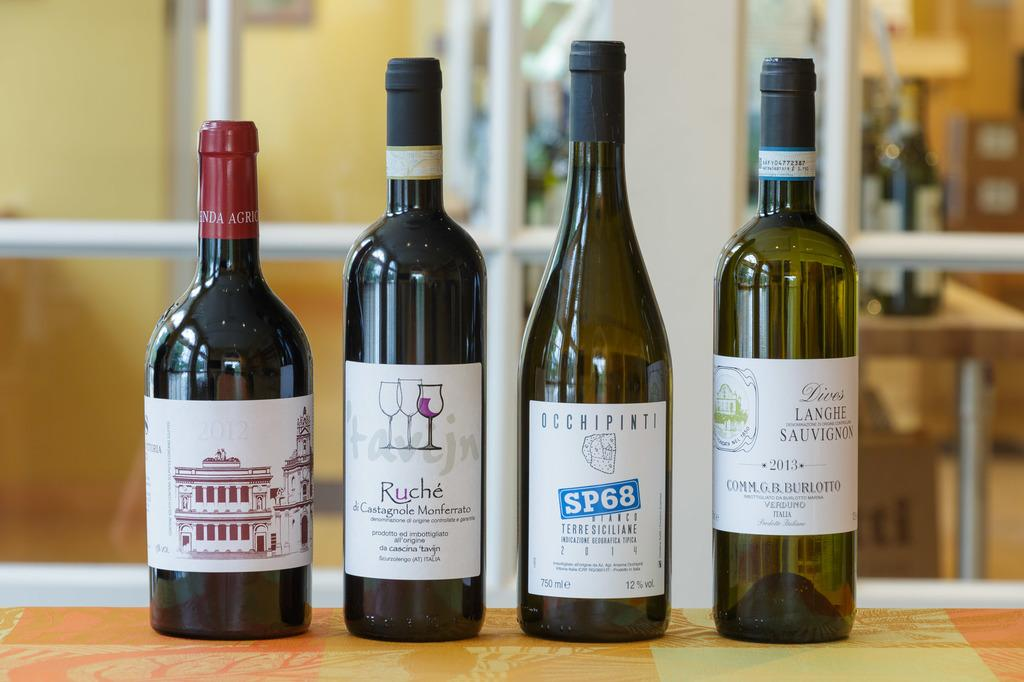<image>
Summarize the visual content of the image. Four wines on a table and featuring the brands Ruche and SP68. 